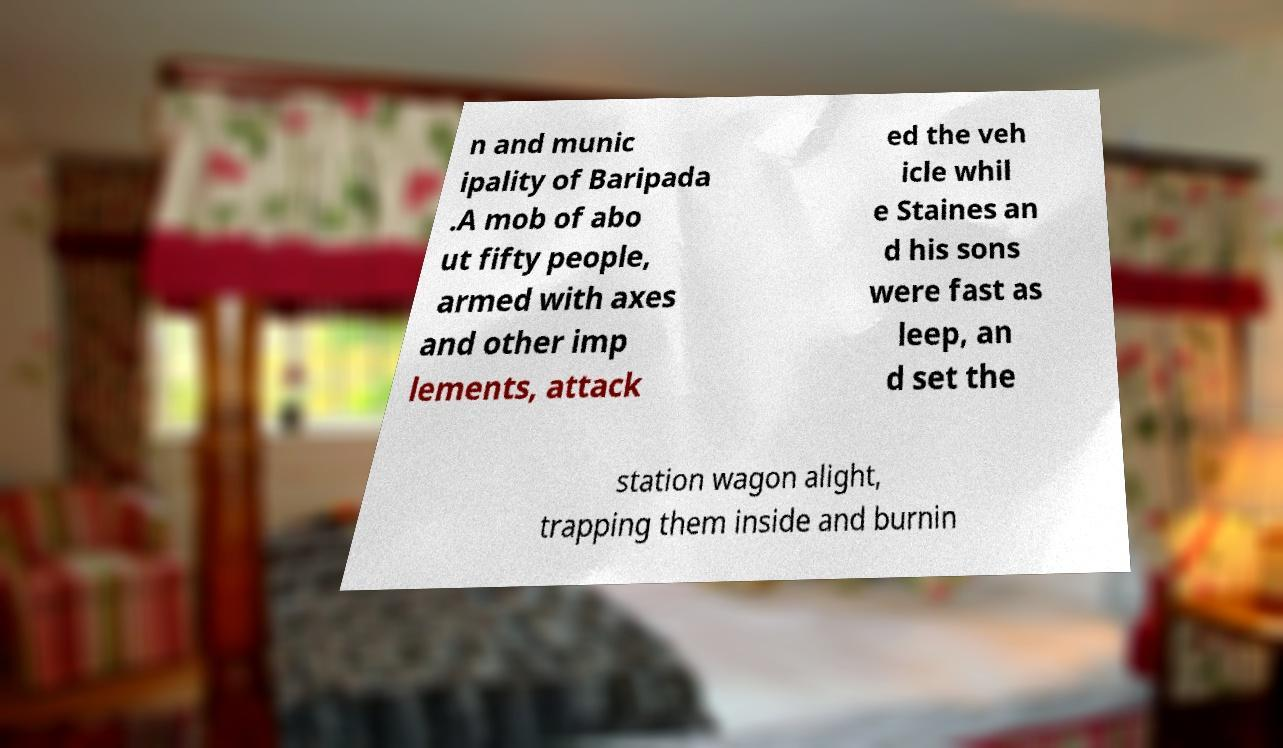For documentation purposes, I need the text within this image transcribed. Could you provide that? n and munic ipality of Baripada .A mob of abo ut fifty people, armed with axes and other imp lements, attack ed the veh icle whil e Staines an d his sons were fast as leep, an d set the station wagon alight, trapping them inside and burnin 